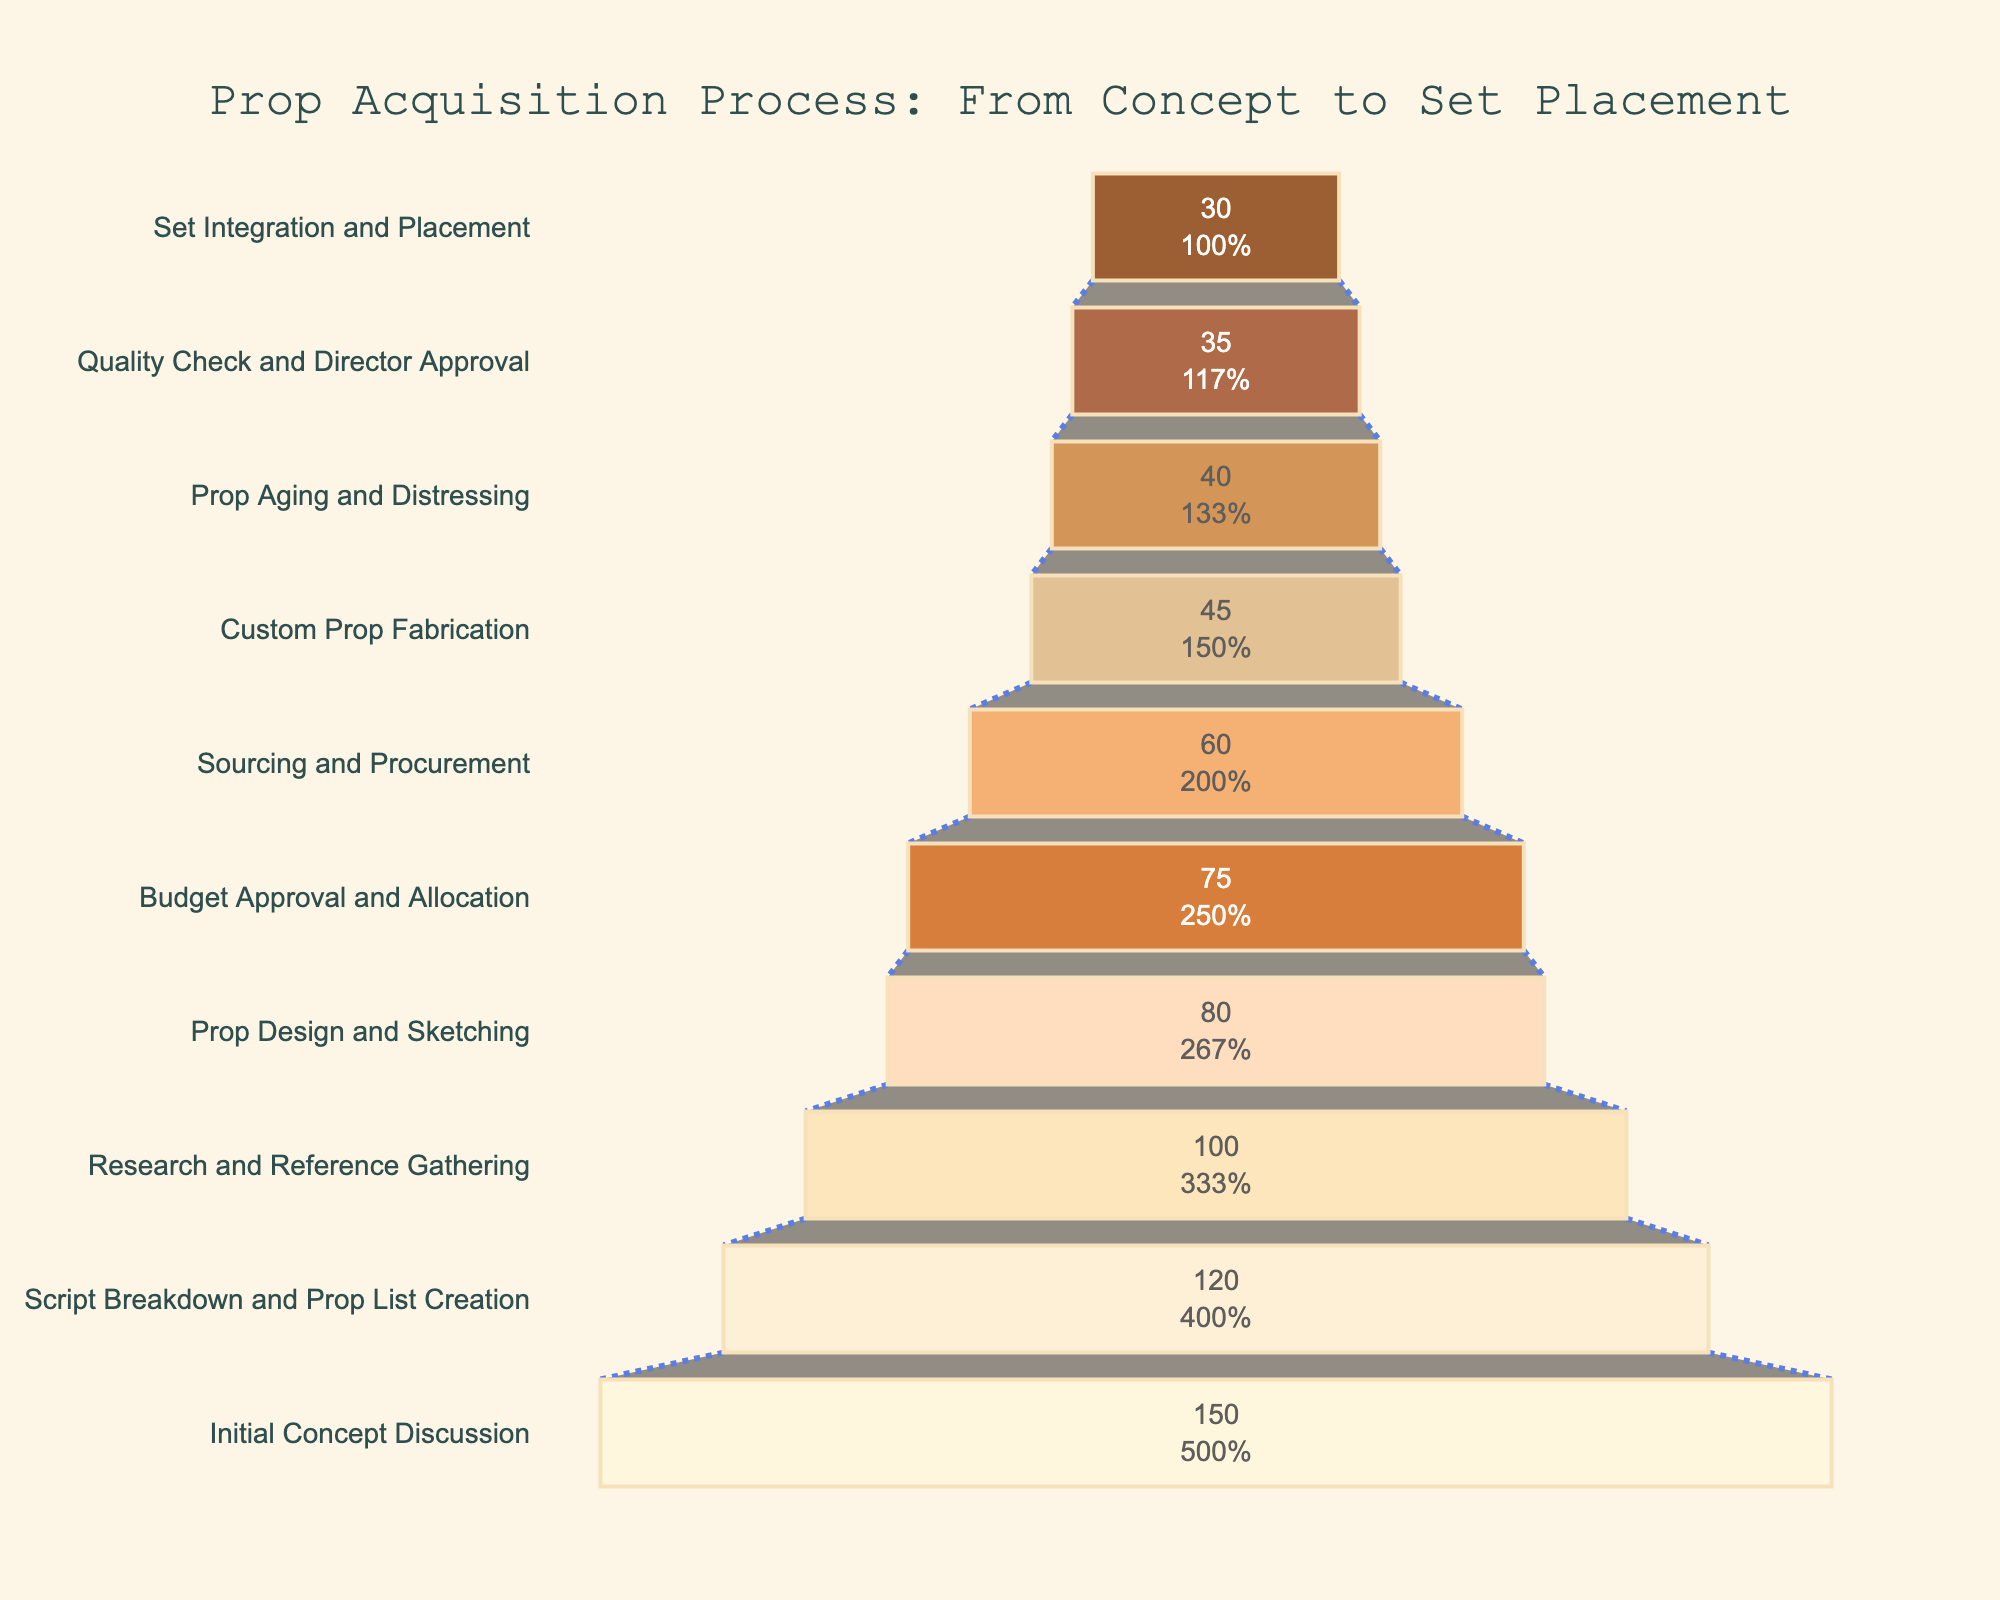What's the title of the funnel chart? The title is placed at the top of the chart, clearly indicating its purpose.
Answer: Prop Acquisition Process: From Concept to Set Placement What is the number of props sourced and procured? The step labeled "Sourcing and Procurement" shows the number of props inside the respective bar.
Answer: 60 Which stage has the highest number of props? The top bar represents the initial stage and typically has the highest count as it captures the broadest scope.
Answer: Initial Concept Discussion How many steps are there in the prop acquisition process? Count the number of distinct stages presented on the Y-axis.
Answer: 10 What percentage of the initial props proceed to the stage of Custom Prop Fabrication? The funnel chart includes text that shows the progress from one stage to the next in percentage terms. Locate the percentage on the "Custom Prop Fabrication" bar relative to the "Initial Concept Discussion".
Answer: 30% By how many props does the number decrease from the stage of Prop Design and Sketching to Prop Aging and Distressing? Subtract the number of props at the "Prop Aging and Distressing" stage from the number at "Prop Design and Sketching".
Answer: 80 - 40 = 40 Compare the number of props at the stage "Research and Reference Gathering" with "Prop Aging and Distressing". Which one has more, and by how much? Look at the numbers shown on the bars for these stages and calculate the difference.
Answer: Research and Reference Gathering has 60 props more than Prop Aging and Distressing What two stages have the smallest number of props? Identify the two bars with the smallest values at the bottom of the funnel chart.
Answer: Set Integration and Placement, and Quality Check and Director Approval By how many props does the quantity reduce from Budget Approval and Allocation to Sourcing and Procurement? Subtract the number of props at the "Sourcing and Procurement" from "Budget Approval and Allocation".
Answer: 75 - 60 = 15 What is the percentage drop from the Initial Concept Discussion to the final Set Integration and Placement? Compare the count of props at the beginning and the final stage and calculate the percentage drop.
Answer: ((150 - 30) / 150) * 100% = 80% 